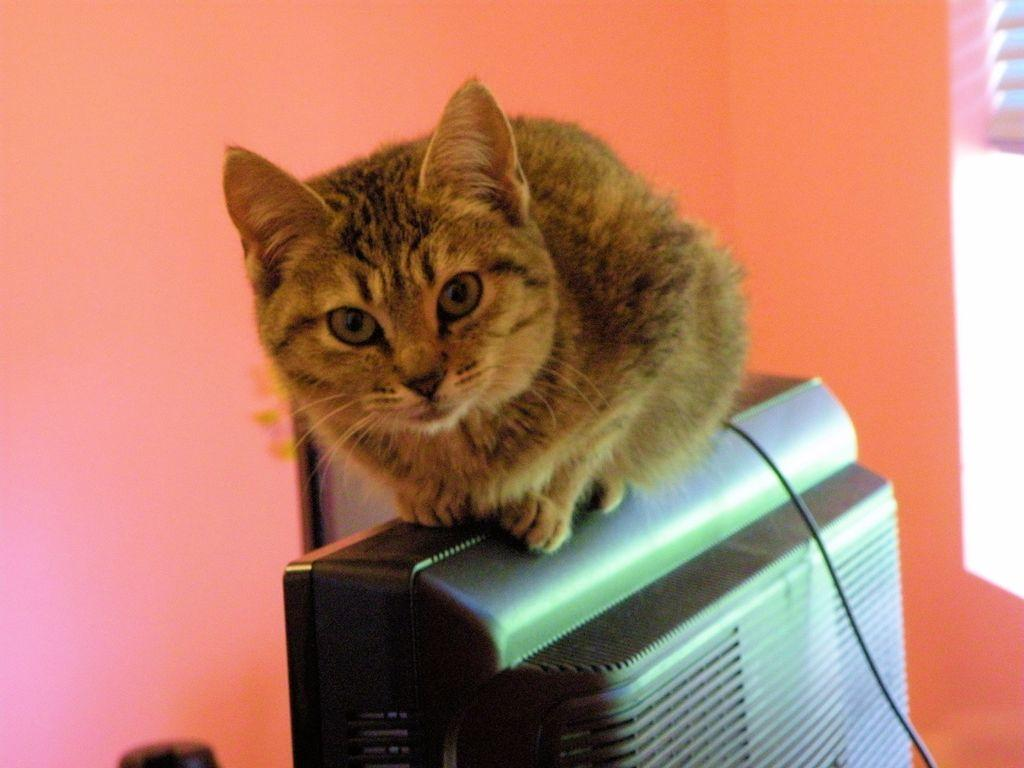What electronic device can be seen in the image? There is a television in the image. What is sitting on top of the television? A cat is sitting on the television. What can be seen in the background of the image? There is a wall in the background of the image. What is visible on the right side of the image? There is a wire visible on the right side of the image. What type of jeans is the fan wearing in the image? There is no fan or jeans present in the image. 